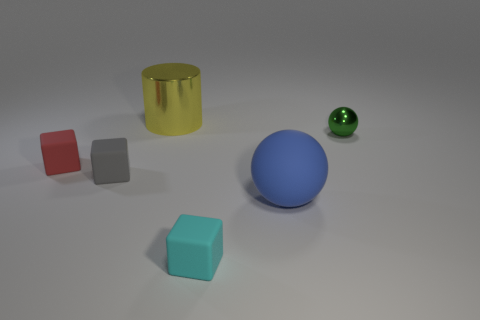How many objects are both on the left side of the large blue matte thing and behind the tiny gray matte thing?
Give a very brief answer. 2. Is the size of the yellow object that is behind the tiny red block the same as the cube to the right of the gray object?
Offer a very short reply. No. What number of objects are small objects that are to the right of the tiny red matte block or red things?
Offer a terse response. 4. There is a tiny object to the right of the cyan cube; what is its material?
Provide a succinct answer. Metal. What is the material of the gray thing?
Give a very brief answer. Rubber. What is the material of the big object that is in front of the shiny thing on the left side of the small matte thing on the right side of the large metal cylinder?
Provide a succinct answer. Rubber. Is there any other thing that is the same material as the small sphere?
Give a very brief answer. Yes. Does the blue rubber object have the same size as the ball that is behind the red rubber cube?
Make the answer very short. No. What number of things are green shiny balls behind the tiny cyan rubber block or tiny objects on the right side of the tiny cyan matte thing?
Offer a very short reply. 1. There is a large thing behind the green shiny sphere; what is its color?
Give a very brief answer. Yellow. 